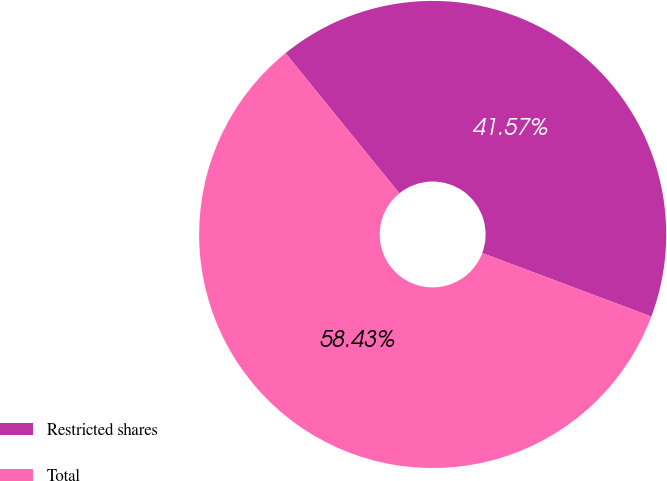<chart> <loc_0><loc_0><loc_500><loc_500><pie_chart><fcel>Restricted shares<fcel>Total<nl><fcel>41.57%<fcel>58.43%<nl></chart> 